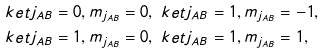Convert formula to latex. <formula><loc_0><loc_0><loc_500><loc_500>& \ k e t { j _ { A B } = 0 , m _ { j _ { A B } } = 0 } , \ k e t { j _ { A B } = 1 , m _ { j _ { A B } } = - 1 } , \\ & \ k e t { j _ { A B } = 1 , m _ { j _ { A B } } = 0 } , \ k e t { j _ { A B } = 1 , m _ { j _ { A B } } = 1 } ,</formula> 